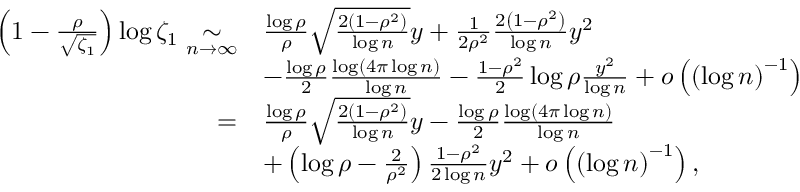<formula> <loc_0><loc_0><loc_500><loc_500>\begin{array} { r l } { \left ( 1 - \frac { \rho } { \sqrt { \zeta _ { 1 } } } \right ) \log \zeta _ { 1 } \underset { n \to \infty } { \sim } } & { \frac { \log \rho } { \rho } \sqrt { \frac { 2 ( 1 - \rho ^ { 2 } ) } { \log n } } y + \frac { 1 } { 2 \rho ^ { 2 } } \frac { 2 \left ( 1 - \rho ^ { 2 } \right ) } { \log n } y ^ { 2 } } \\ & { - \frac { \log \rho } { 2 } \frac { \log \left ( 4 \pi \log n \right ) } { \log n } - \frac { 1 - \rho ^ { 2 } } { 2 } \log \rho \frac { y ^ { 2 } } { \log n } + o \left ( { ( \log n ) } ^ { - 1 } \right ) } \\ { = } & { \frac { \log \rho } { \rho } \sqrt { \frac { 2 ( 1 - \rho ^ { 2 } ) } { \log n } } y - \frac { \log \rho } 2 \frac { \log \left ( 4 \pi \log n \right ) } { \log n } } \\ & { + \left ( \log \rho - \frac { 2 } \rho ^ { 2 } } \right ) \frac { 1 - \rho ^ { 2 } } { 2 \log n } y ^ { 2 } + o \left ( { ( \log n ) } ^ { - 1 } \right ) , } \end{array}</formula> 